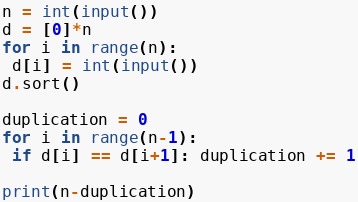<code> <loc_0><loc_0><loc_500><loc_500><_Python_>n = int(input())
d = [0]*n
for i in range(n):
 d[i] = int(input())
d.sort()

duplication = 0
for i in range(n-1):
 if d[i] == d[i+1]: duplication += 1

print(n-duplication)</code> 